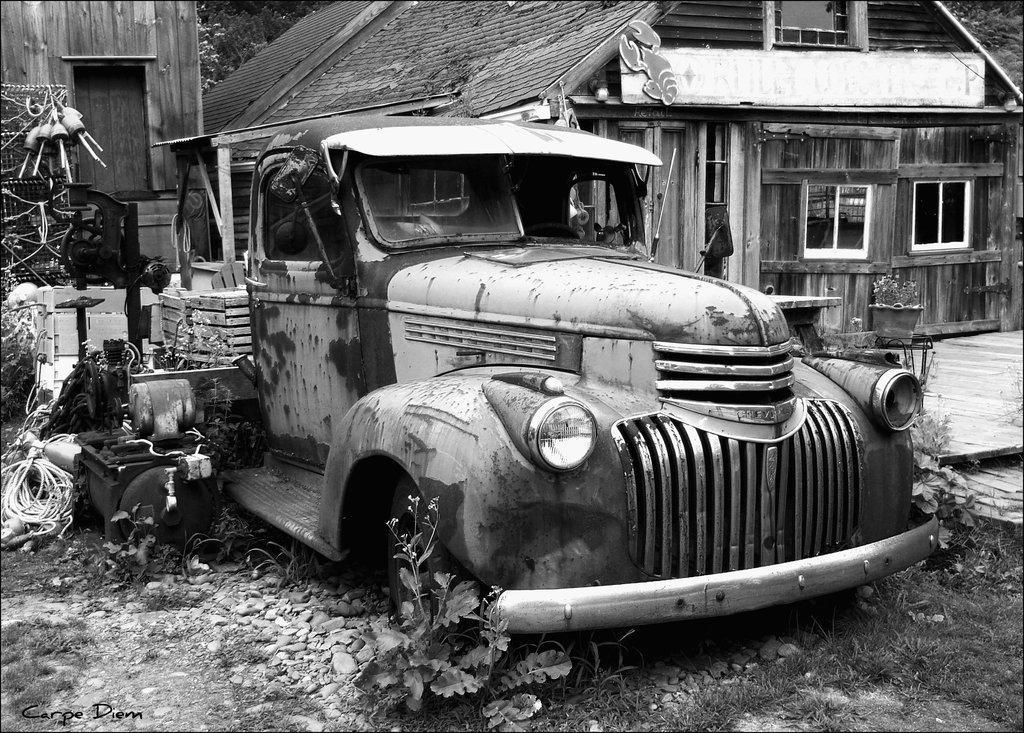How would you summarize this image in a sentence or two? It is a black and white image,there is a wooden house and in front of the house there is a damaged vehicle,there are some objects kept behind the vehicle. 